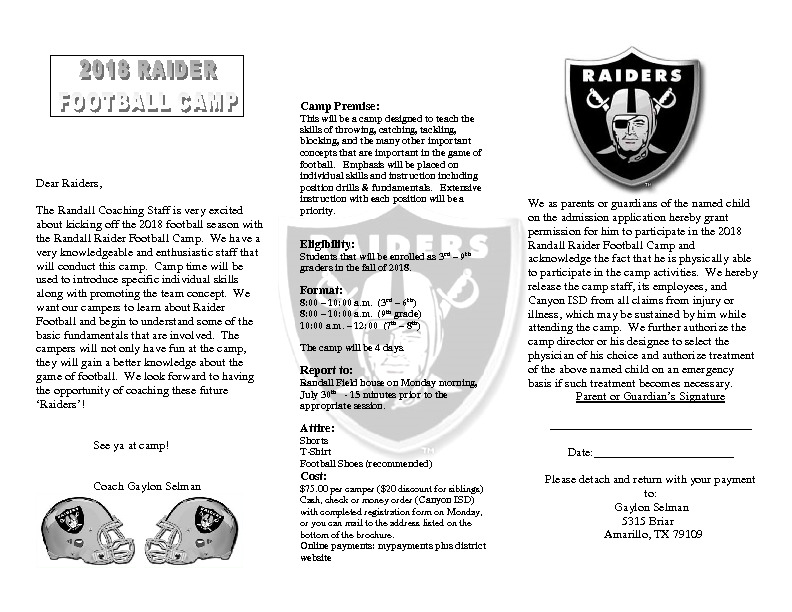Based on the attire requirements listed for the camp, what might be the reason for recommending but not mandating football shoes, and what does this suggest about the nature of the activities at the camp? The recommendation but not the mandate of football shoes suggests that while the camp does include activities where specialized footwear such as football shoes could be beneficial—like specific drills, blocking, and tackling—the organizers want to make the camp accessible to all children, regardless of whether they own such shoes. This thoughtful approach ensures that no camper is excluded due to lack of equipment, promoting inclusivity and ensuring all children can participate. Additionally, this implies that the camp focuses more on learning, skill-building, and development rather than high-stakes competitive play, where specialized equipment would be more critical. By emphasizing inclusivity and ensuring accessibility, the camp aims to provide instructional and developmental opportunities to all its participants. 